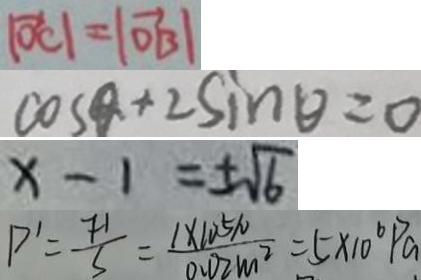Convert formula to latex. <formula><loc_0><loc_0><loc_500><loc_500>\vert \overrightarrow { O C } \vert = \vert \overrightarrow { O B \vert } 
 \cos \theta + 2 \sin \theta = 0 
 x - 1 = \pm \sqrt { 6 } 
 P ^ { \prime } = \frac { F ^ { \prime } } { S } = \frac { 1 \times 1 0 ^ { 5 } N } { 0 . 0 2 m ^ { 2 } } = 5 \times 1 0 ^ { 6 } P a</formula> 